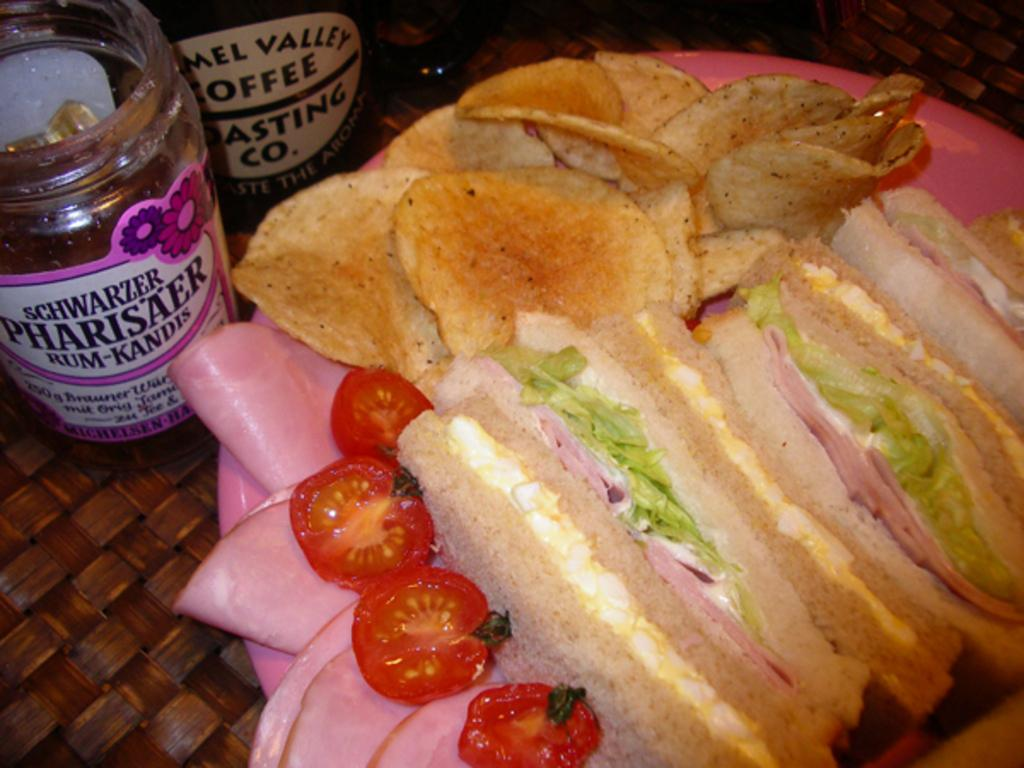What is on the plate that is visible in the image? There is food in a plate in the image. Where is the plate located in the image? The plate is placed on a surface in the image. What else can be seen near the plate in the image? There are containers beside the plate in the image. Is there a bomb hidden under the plate in the image? No, there is no bomb present in the image. 